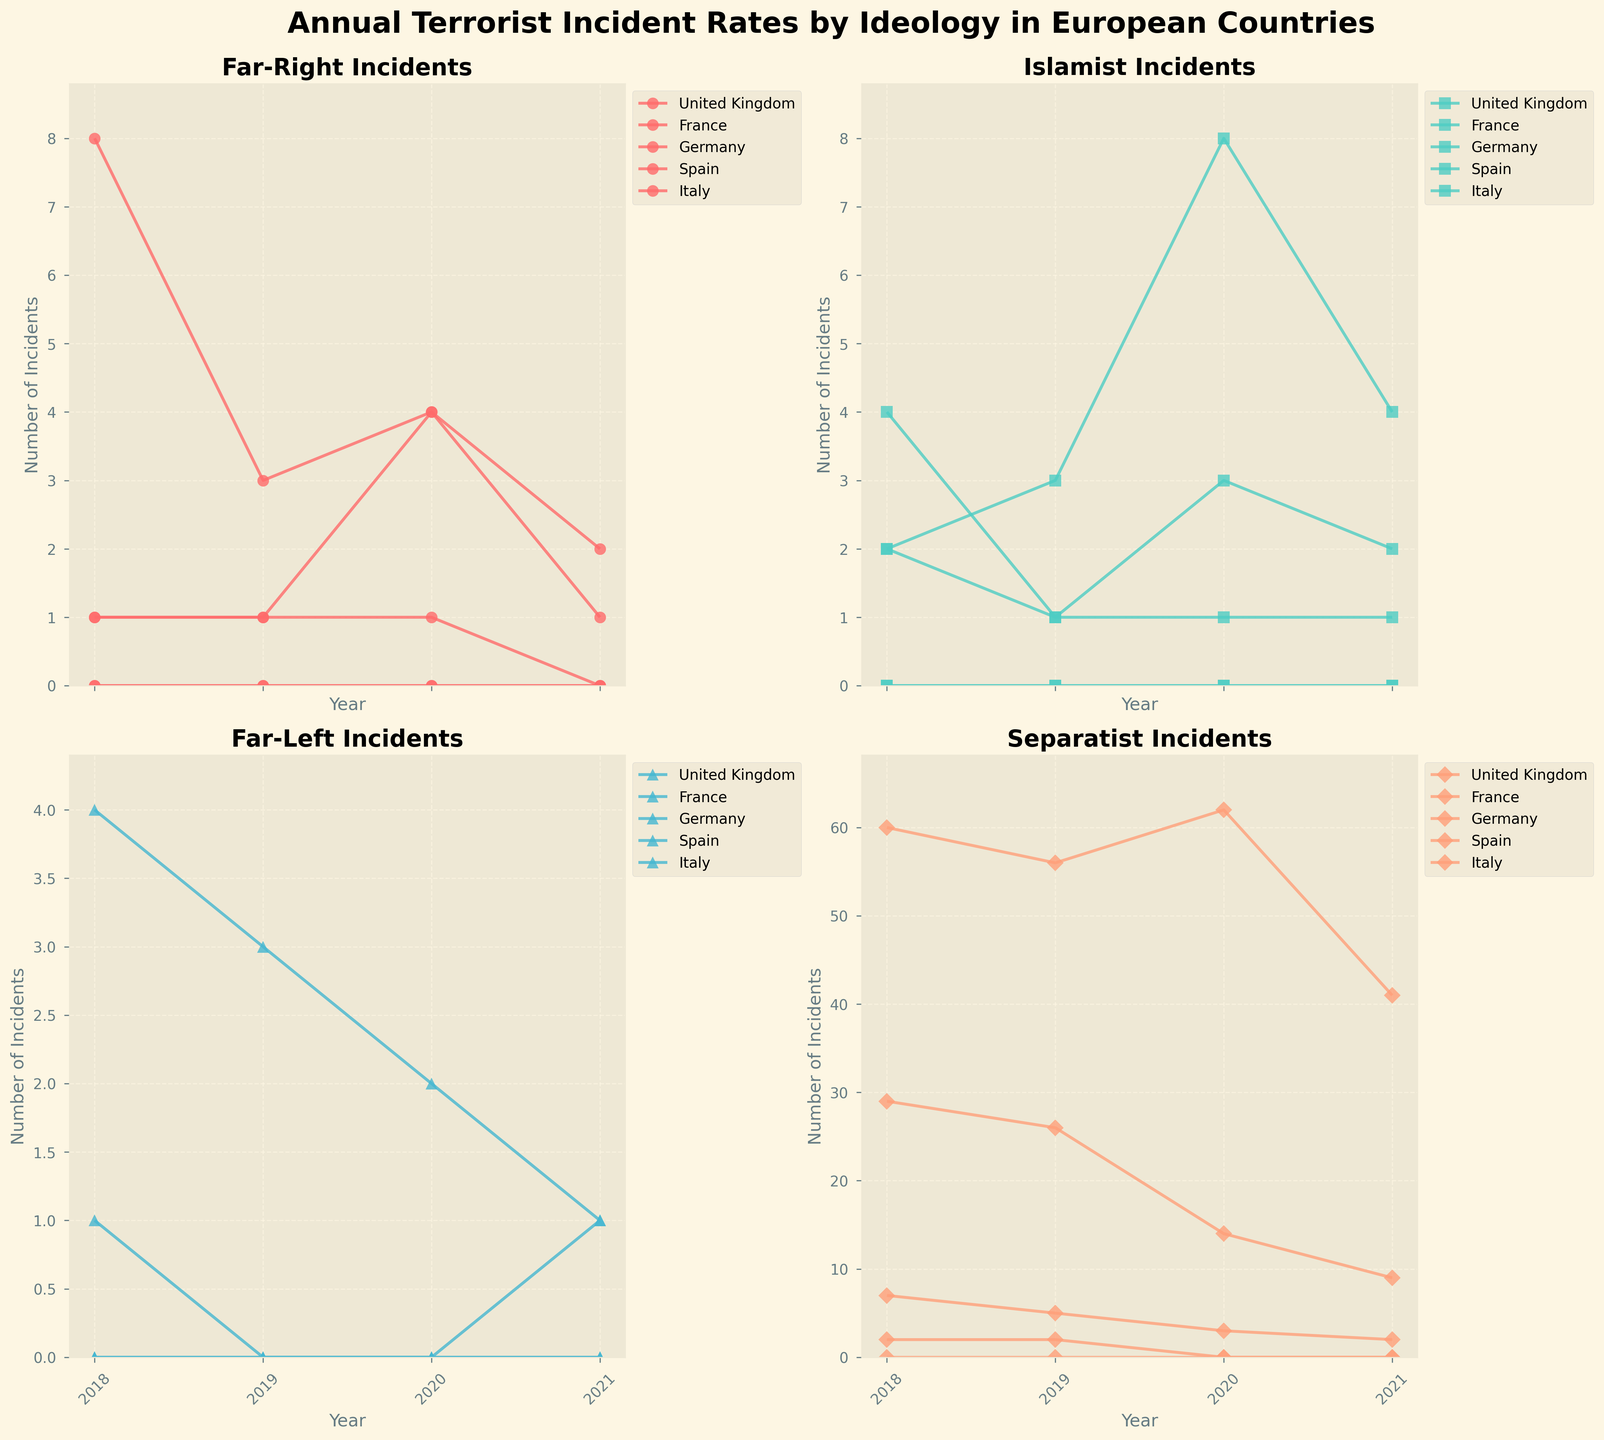Which country had the highest number of far-right incidents in 2020? Looking at the 'Far-Right Incidents' subplot and the year 2020, the highest point is for Germany with 4 incidents.
Answer: Germany Did the number of separatist incidents in the United Kingdom increase or decrease from 2018 to 2021? The 'Separatist Incidents' subplot shows that in the United Kingdom, the number decreased from 60 in 2018 to 41 in 2021.
Answer: Decrease Which ideology had the highest number of incidents in France in 2020? In the 'France 2020' data across the subplots, the highest number is under Islamist Incidents with 8 incidents.
Answer: Islamist What was the trend in far-left incidents in Italy from 2018 to 2021? Observing the 'Far-Left Incidents' subplot, the points for Italy are 4 (2018), 3 (2019), 2 (2020), and 1 (2021), showing a decreasing trend over the years.
Answer: Decreasing How many total incidents were recorded in Spain in 2019 across all ideologies? Adding up the values from all subplots for Spain in 2019, the total is 0+0+0+5 = 5.
Answer: 5 Compare the far-right incidents in Germany in 2018 and 2021. Which year had more incidents? In the 'Far-Right Incidents' subplot, Germany had 1 incident in 2018 and 1 incident in 2021, meaning both years had the same number of incidents.
Answer: Same Which European country experienced the most significant reduction in far-right incidents from 2018 to 2019? By comparing the first two years in the 'Far-Right Incidents' subplot, the United Kingdom had 8 incidents in 2018 and 3 in 2019, a reduction of 5, which is the most significant reduction.
Answer: United Kingdom Was there any year when Spain had more than 0 Islamist incidents? Checking the 'Islamist Incidents' subplot for Spain from 2018 to 2021, all values are 0 each year.
Answer: No Which country had consistently low separatist incidents (<= 2) throughout the years? By examining the 'Separatist Incidents' subplot, both Germany and Italy have 2 or fewer incidents each year from 2018 to 2021.
Answer: Germany and Italy 